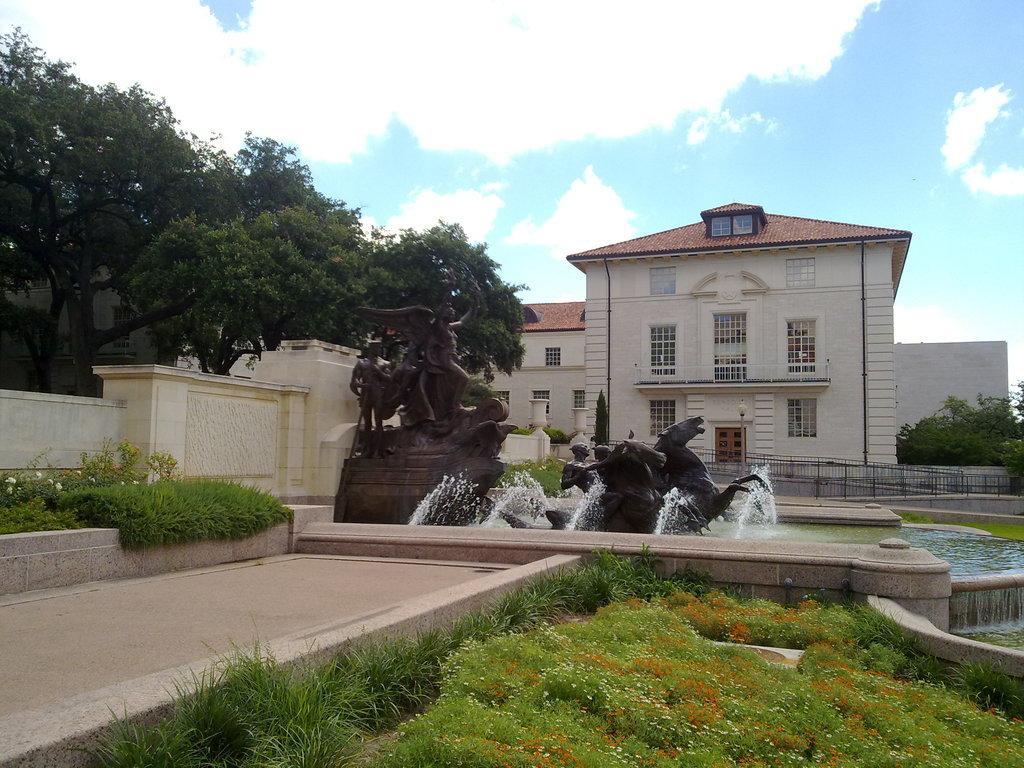How would you summarize this image in a sentence or two? In this image, on the left side, we can see a wall, trees, plant with some flowers and a grass. On the right corner, we can see some plants, flowers and a grass. On the right side, we can also see some trees, water. In the middle of the image, we can see some statues. In the background, we can see a building, window. At the top, we can see a sky which is a bit cloudy, at the bottom, we can see a land. 